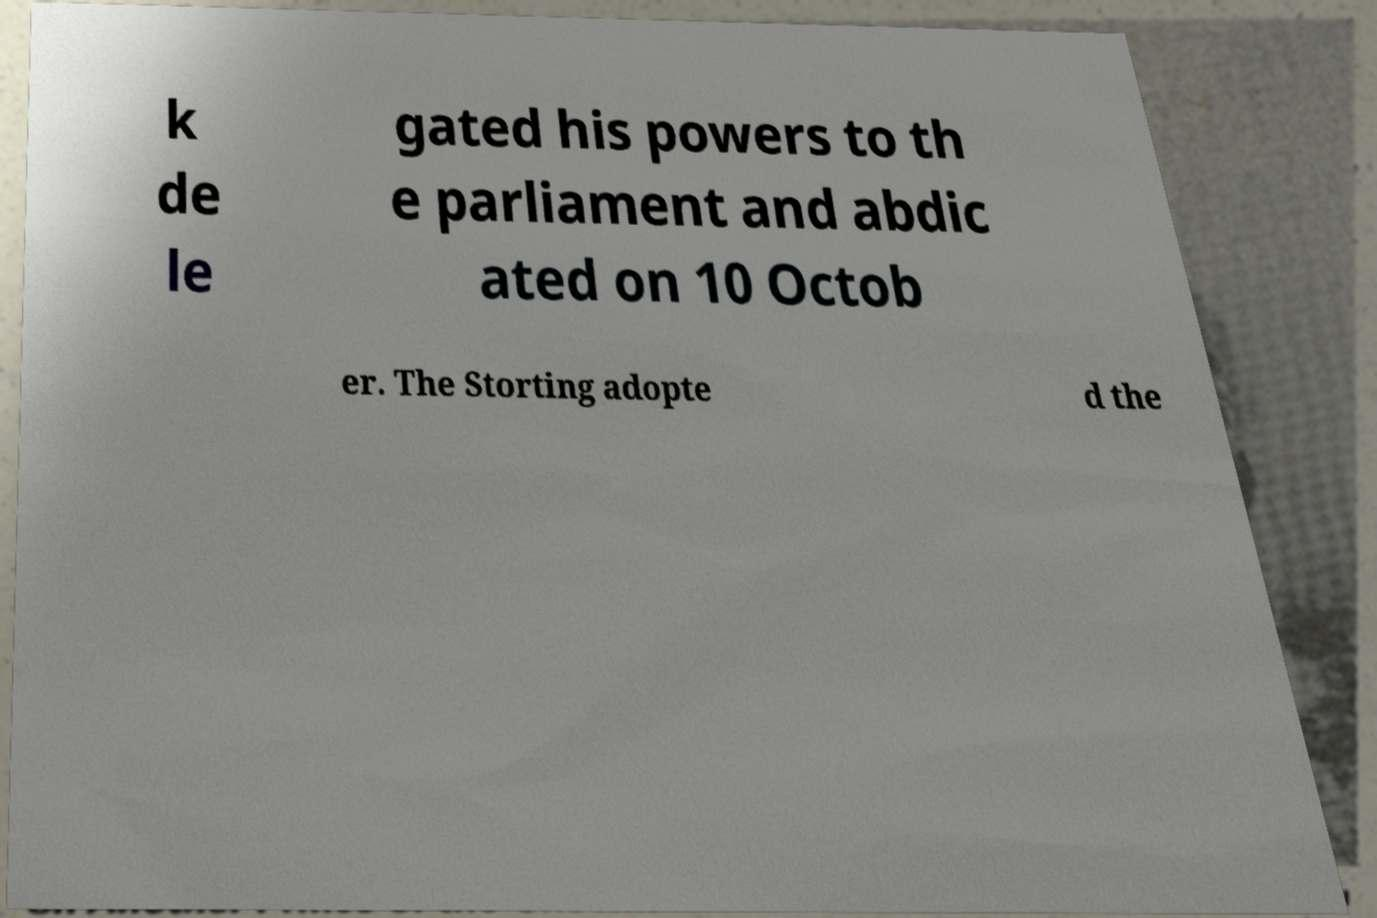For documentation purposes, I need the text within this image transcribed. Could you provide that? k de le gated his powers to th e parliament and abdic ated on 10 Octob er. The Storting adopte d the 